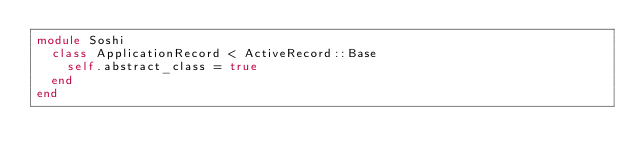<code> <loc_0><loc_0><loc_500><loc_500><_Ruby_>module Soshi
  class ApplicationRecord < ActiveRecord::Base
    self.abstract_class = true
  end
end
</code> 